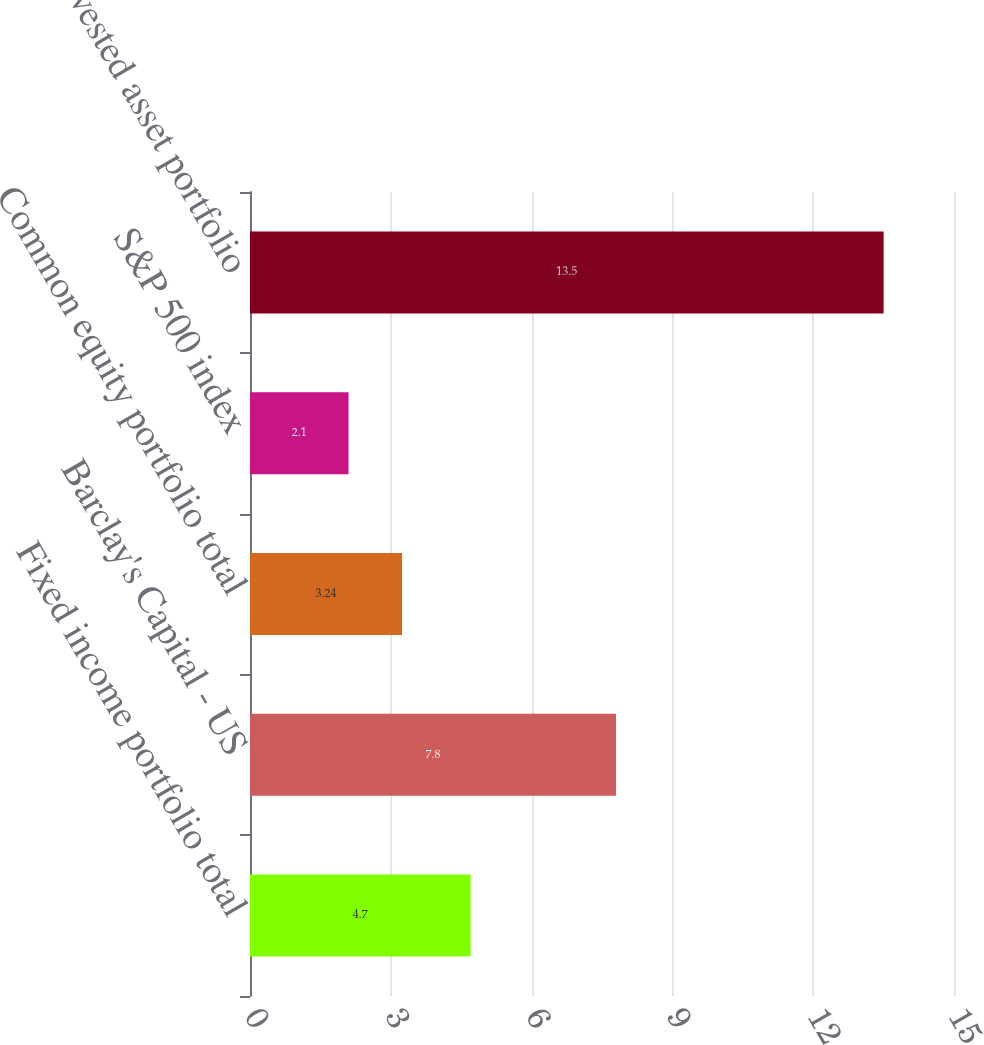<chart> <loc_0><loc_0><loc_500><loc_500><bar_chart><fcel>Fixed income portfolio total<fcel>Barclay's Capital - US<fcel>Common equity portfolio total<fcel>S&P 500 index<fcel>Other invested asset portfolio<nl><fcel>4.7<fcel>7.8<fcel>3.24<fcel>2.1<fcel>13.5<nl></chart> 